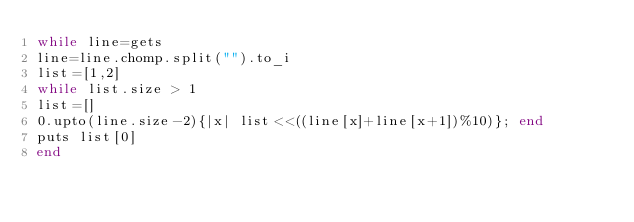Convert code to text. <code><loc_0><loc_0><loc_500><loc_500><_Ruby_>while line=gets
line=line.chomp.split("").to_i 
list=[1,2]
while list.size > 1
list=[]
0.upto(line.size-2){|x| list<<((line[x]+line[x+1])%10)}; end
puts list[0]
end </code> 